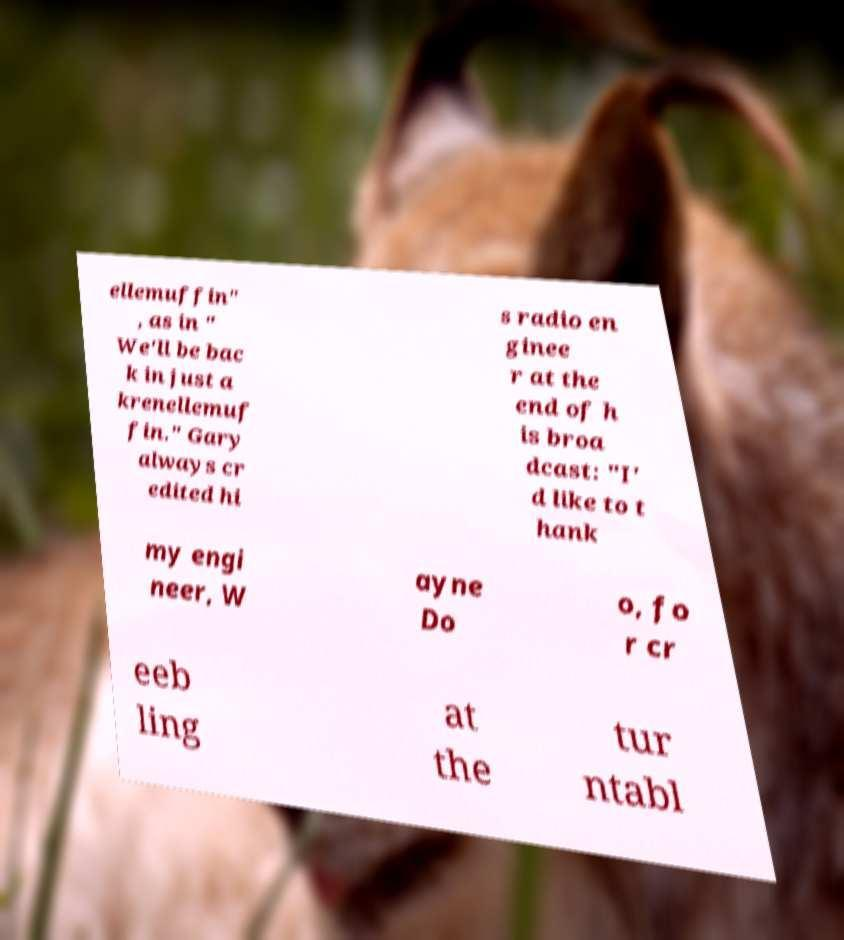There's text embedded in this image that I need extracted. Can you transcribe it verbatim? ellemuffin" , as in " We'll be bac k in just a krenellemuf fin." Gary always cr edited hi s radio en ginee r at the end of h is broa dcast: "I' d like to t hank my engi neer, W ayne Do o, fo r cr eeb ling at the tur ntabl 